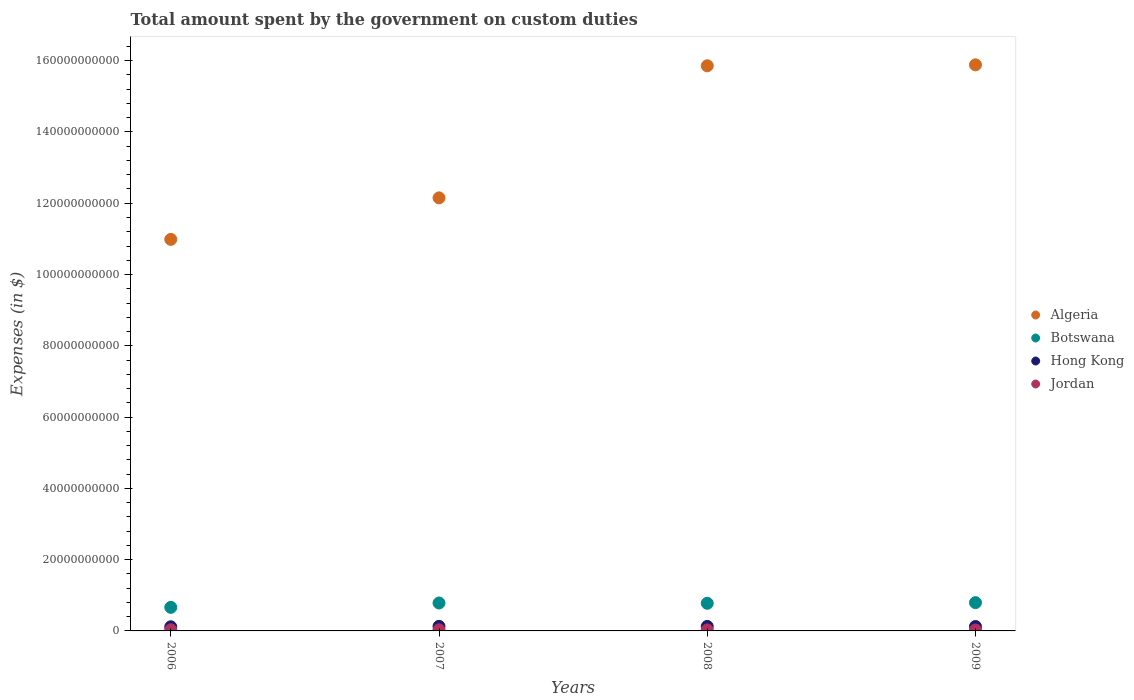Is the number of dotlines equal to the number of legend labels?
Your response must be concise. Yes. What is the amount spent on custom duties by the government in Algeria in 2009?
Give a very brief answer. 1.59e+11. Across all years, what is the maximum amount spent on custom duties by the government in Hong Kong?
Ensure brevity in your answer.  1.28e+09. Across all years, what is the minimum amount spent on custom duties by the government in Algeria?
Your answer should be compact. 1.10e+11. In which year was the amount spent on custom duties by the government in Jordan minimum?
Your response must be concise. 2009. What is the total amount spent on custom duties by the government in Botswana in the graph?
Your response must be concise. 3.01e+1. What is the difference between the amount spent on custom duties by the government in Hong Kong in 2007 and that in 2009?
Make the answer very short. 4.30e+07. What is the difference between the amount spent on custom duties by the government in Algeria in 2008 and the amount spent on custom duties by the government in Jordan in 2007?
Ensure brevity in your answer.  1.58e+11. What is the average amount spent on custom duties by the government in Botswana per year?
Give a very brief answer. 7.53e+09. In the year 2007, what is the difference between the amount spent on custom duties by the government in Algeria and amount spent on custom duties by the government in Jordan?
Your answer should be very brief. 1.21e+11. What is the ratio of the amount spent on custom duties by the government in Botswana in 2006 to that in 2007?
Provide a short and direct response. 0.84. Is the amount spent on custom duties by the government in Hong Kong in 2006 less than that in 2007?
Provide a short and direct response. Yes. What is the difference between the highest and the second highest amount spent on custom duties by the government in Botswana?
Your answer should be compact. 9.62e+07. What is the difference between the highest and the lowest amount spent on custom duties by the government in Jordan?
Offer a terse response. 4.53e+07. In how many years, is the amount spent on custom duties by the government in Botswana greater than the average amount spent on custom duties by the government in Botswana taken over all years?
Keep it short and to the point. 3. Is the sum of the amount spent on custom duties by the government in Botswana in 2007 and 2008 greater than the maximum amount spent on custom duties by the government in Algeria across all years?
Make the answer very short. No. Is it the case that in every year, the sum of the amount spent on custom duties by the government in Hong Kong and amount spent on custom duties by the government in Botswana  is greater than the sum of amount spent on custom duties by the government in Algeria and amount spent on custom duties by the government in Jordan?
Ensure brevity in your answer.  Yes. Is it the case that in every year, the sum of the amount spent on custom duties by the government in Botswana and amount spent on custom duties by the government in Algeria  is greater than the amount spent on custom duties by the government in Jordan?
Offer a very short reply. Yes. Is the amount spent on custom duties by the government in Algeria strictly greater than the amount spent on custom duties by the government in Hong Kong over the years?
Your answer should be compact. Yes. How many dotlines are there?
Your answer should be compact. 4. How many years are there in the graph?
Make the answer very short. 4. Does the graph contain any zero values?
Keep it short and to the point. No. How are the legend labels stacked?
Your answer should be compact. Vertical. What is the title of the graph?
Offer a terse response. Total amount spent by the government on custom duties. Does "Croatia" appear as one of the legend labels in the graph?
Ensure brevity in your answer.  No. What is the label or title of the X-axis?
Make the answer very short. Years. What is the label or title of the Y-axis?
Keep it short and to the point. Expenses (in $). What is the Expenses (in $) in Algeria in 2006?
Provide a short and direct response. 1.10e+11. What is the Expenses (in $) in Botswana in 2006?
Give a very brief answer. 6.61e+09. What is the Expenses (in $) in Hong Kong in 2006?
Your response must be concise. 1.16e+09. What is the Expenses (in $) in Jordan in 2006?
Your response must be concise. 3.16e+08. What is the Expenses (in $) in Algeria in 2007?
Keep it short and to the point. 1.22e+11. What is the Expenses (in $) of Botswana in 2007?
Provide a succinct answer. 7.83e+09. What is the Expenses (in $) in Hong Kong in 2007?
Your response must be concise. 1.28e+09. What is the Expenses (in $) of Jordan in 2007?
Keep it short and to the point. 3.12e+08. What is the Expenses (in $) of Algeria in 2008?
Keep it short and to the point. 1.59e+11. What is the Expenses (in $) of Botswana in 2008?
Make the answer very short. 7.75e+09. What is the Expenses (in $) of Hong Kong in 2008?
Provide a short and direct response. 1.26e+09. What is the Expenses (in $) of Jordan in 2008?
Your response must be concise. 2.84e+08. What is the Expenses (in $) in Algeria in 2009?
Your answer should be very brief. 1.59e+11. What is the Expenses (in $) in Botswana in 2009?
Offer a very short reply. 7.93e+09. What is the Expenses (in $) of Hong Kong in 2009?
Your response must be concise. 1.24e+09. What is the Expenses (in $) of Jordan in 2009?
Offer a terse response. 2.70e+08. Across all years, what is the maximum Expenses (in $) of Algeria?
Your response must be concise. 1.59e+11. Across all years, what is the maximum Expenses (in $) of Botswana?
Make the answer very short. 7.93e+09. Across all years, what is the maximum Expenses (in $) in Hong Kong?
Keep it short and to the point. 1.28e+09. Across all years, what is the maximum Expenses (in $) of Jordan?
Give a very brief answer. 3.16e+08. Across all years, what is the minimum Expenses (in $) in Algeria?
Your answer should be very brief. 1.10e+11. Across all years, what is the minimum Expenses (in $) in Botswana?
Offer a terse response. 6.61e+09. Across all years, what is the minimum Expenses (in $) in Hong Kong?
Your response must be concise. 1.16e+09. Across all years, what is the minimum Expenses (in $) in Jordan?
Offer a very short reply. 2.70e+08. What is the total Expenses (in $) in Algeria in the graph?
Your answer should be compact. 5.49e+11. What is the total Expenses (in $) in Botswana in the graph?
Give a very brief answer. 3.01e+1. What is the total Expenses (in $) in Hong Kong in the graph?
Ensure brevity in your answer.  4.94e+09. What is the total Expenses (in $) of Jordan in the graph?
Make the answer very short. 1.18e+09. What is the difference between the Expenses (in $) in Algeria in 2006 and that in 2007?
Make the answer very short. -1.16e+1. What is the difference between the Expenses (in $) in Botswana in 2006 and that in 2007?
Your response must be concise. -1.22e+09. What is the difference between the Expenses (in $) of Hong Kong in 2006 and that in 2007?
Your answer should be very brief. -1.18e+08. What is the difference between the Expenses (in $) of Jordan in 2006 and that in 2007?
Offer a very short reply. 3.54e+06. What is the difference between the Expenses (in $) in Algeria in 2006 and that in 2008?
Ensure brevity in your answer.  -4.87e+1. What is the difference between the Expenses (in $) of Botswana in 2006 and that in 2008?
Keep it short and to the point. -1.14e+09. What is the difference between the Expenses (in $) of Hong Kong in 2006 and that in 2008?
Your response must be concise. -1.02e+08. What is the difference between the Expenses (in $) in Jordan in 2006 and that in 2008?
Your answer should be very brief. 3.12e+07. What is the difference between the Expenses (in $) of Algeria in 2006 and that in 2009?
Your answer should be very brief. -4.90e+1. What is the difference between the Expenses (in $) in Botswana in 2006 and that in 2009?
Offer a terse response. -1.32e+09. What is the difference between the Expenses (in $) in Hong Kong in 2006 and that in 2009?
Provide a short and direct response. -7.50e+07. What is the difference between the Expenses (in $) in Jordan in 2006 and that in 2009?
Ensure brevity in your answer.  4.53e+07. What is the difference between the Expenses (in $) in Algeria in 2007 and that in 2008?
Ensure brevity in your answer.  -3.71e+1. What is the difference between the Expenses (in $) of Botswana in 2007 and that in 2008?
Provide a short and direct response. 8.47e+07. What is the difference between the Expenses (in $) in Hong Kong in 2007 and that in 2008?
Offer a very short reply. 1.60e+07. What is the difference between the Expenses (in $) in Jordan in 2007 and that in 2008?
Make the answer very short. 2.77e+07. What is the difference between the Expenses (in $) in Algeria in 2007 and that in 2009?
Offer a very short reply. -3.73e+1. What is the difference between the Expenses (in $) of Botswana in 2007 and that in 2009?
Your response must be concise. -9.62e+07. What is the difference between the Expenses (in $) of Hong Kong in 2007 and that in 2009?
Keep it short and to the point. 4.30e+07. What is the difference between the Expenses (in $) in Jordan in 2007 and that in 2009?
Your answer should be compact. 4.18e+07. What is the difference between the Expenses (in $) of Algeria in 2008 and that in 2009?
Keep it short and to the point. -2.69e+08. What is the difference between the Expenses (in $) in Botswana in 2008 and that in 2009?
Keep it short and to the point. -1.81e+08. What is the difference between the Expenses (in $) of Hong Kong in 2008 and that in 2009?
Offer a terse response. 2.70e+07. What is the difference between the Expenses (in $) of Jordan in 2008 and that in 2009?
Your response must be concise. 1.41e+07. What is the difference between the Expenses (in $) of Algeria in 2006 and the Expenses (in $) of Botswana in 2007?
Ensure brevity in your answer.  1.02e+11. What is the difference between the Expenses (in $) in Algeria in 2006 and the Expenses (in $) in Hong Kong in 2007?
Ensure brevity in your answer.  1.09e+11. What is the difference between the Expenses (in $) in Algeria in 2006 and the Expenses (in $) in Jordan in 2007?
Offer a very short reply. 1.10e+11. What is the difference between the Expenses (in $) of Botswana in 2006 and the Expenses (in $) of Hong Kong in 2007?
Your answer should be very brief. 5.33e+09. What is the difference between the Expenses (in $) of Botswana in 2006 and the Expenses (in $) of Jordan in 2007?
Offer a very short reply. 6.30e+09. What is the difference between the Expenses (in $) of Hong Kong in 2006 and the Expenses (in $) of Jordan in 2007?
Give a very brief answer. 8.49e+08. What is the difference between the Expenses (in $) in Algeria in 2006 and the Expenses (in $) in Botswana in 2008?
Make the answer very short. 1.02e+11. What is the difference between the Expenses (in $) in Algeria in 2006 and the Expenses (in $) in Hong Kong in 2008?
Offer a very short reply. 1.09e+11. What is the difference between the Expenses (in $) of Algeria in 2006 and the Expenses (in $) of Jordan in 2008?
Give a very brief answer. 1.10e+11. What is the difference between the Expenses (in $) in Botswana in 2006 and the Expenses (in $) in Hong Kong in 2008?
Offer a terse response. 5.35e+09. What is the difference between the Expenses (in $) in Botswana in 2006 and the Expenses (in $) in Jordan in 2008?
Your answer should be very brief. 6.33e+09. What is the difference between the Expenses (in $) of Hong Kong in 2006 and the Expenses (in $) of Jordan in 2008?
Your response must be concise. 8.77e+08. What is the difference between the Expenses (in $) in Algeria in 2006 and the Expenses (in $) in Botswana in 2009?
Provide a succinct answer. 1.02e+11. What is the difference between the Expenses (in $) of Algeria in 2006 and the Expenses (in $) of Hong Kong in 2009?
Keep it short and to the point. 1.09e+11. What is the difference between the Expenses (in $) of Algeria in 2006 and the Expenses (in $) of Jordan in 2009?
Your response must be concise. 1.10e+11. What is the difference between the Expenses (in $) in Botswana in 2006 and the Expenses (in $) in Hong Kong in 2009?
Your response must be concise. 5.37e+09. What is the difference between the Expenses (in $) of Botswana in 2006 and the Expenses (in $) of Jordan in 2009?
Your answer should be very brief. 6.34e+09. What is the difference between the Expenses (in $) in Hong Kong in 2006 and the Expenses (in $) in Jordan in 2009?
Keep it short and to the point. 8.91e+08. What is the difference between the Expenses (in $) in Algeria in 2007 and the Expenses (in $) in Botswana in 2008?
Provide a succinct answer. 1.14e+11. What is the difference between the Expenses (in $) in Algeria in 2007 and the Expenses (in $) in Hong Kong in 2008?
Your answer should be compact. 1.20e+11. What is the difference between the Expenses (in $) in Algeria in 2007 and the Expenses (in $) in Jordan in 2008?
Give a very brief answer. 1.21e+11. What is the difference between the Expenses (in $) of Botswana in 2007 and the Expenses (in $) of Hong Kong in 2008?
Your response must be concise. 6.57e+09. What is the difference between the Expenses (in $) of Botswana in 2007 and the Expenses (in $) of Jordan in 2008?
Offer a very short reply. 7.55e+09. What is the difference between the Expenses (in $) of Hong Kong in 2007 and the Expenses (in $) of Jordan in 2008?
Your response must be concise. 9.95e+08. What is the difference between the Expenses (in $) of Algeria in 2007 and the Expenses (in $) of Botswana in 2009?
Your answer should be compact. 1.14e+11. What is the difference between the Expenses (in $) in Algeria in 2007 and the Expenses (in $) in Hong Kong in 2009?
Offer a terse response. 1.20e+11. What is the difference between the Expenses (in $) in Algeria in 2007 and the Expenses (in $) in Jordan in 2009?
Your answer should be compact. 1.21e+11. What is the difference between the Expenses (in $) in Botswana in 2007 and the Expenses (in $) in Hong Kong in 2009?
Keep it short and to the point. 6.60e+09. What is the difference between the Expenses (in $) of Botswana in 2007 and the Expenses (in $) of Jordan in 2009?
Provide a short and direct response. 7.56e+09. What is the difference between the Expenses (in $) in Hong Kong in 2007 and the Expenses (in $) in Jordan in 2009?
Make the answer very short. 1.01e+09. What is the difference between the Expenses (in $) of Algeria in 2008 and the Expenses (in $) of Botswana in 2009?
Provide a succinct answer. 1.51e+11. What is the difference between the Expenses (in $) of Algeria in 2008 and the Expenses (in $) of Hong Kong in 2009?
Make the answer very short. 1.57e+11. What is the difference between the Expenses (in $) of Algeria in 2008 and the Expenses (in $) of Jordan in 2009?
Offer a very short reply. 1.58e+11. What is the difference between the Expenses (in $) of Botswana in 2008 and the Expenses (in $) of Hong Kong in 2009?
Offer a terse response. 6.51e+09. What is the difference between the Expenses (in $) in Botswana in 2008 and the Expenses (in $) in Jordan in 2009?
Ensure brevity in your answer.  7.48e+09. What is the difference between the Expenses (in $) in Hong Kong in 2008 and the Expenses (in $) in Jordan in 2009?
Your answer should be compact. 9.93e+08. What is the average Expenses (in $) of Algeria per year?
Provide a short and direct response. 1.37e+11. What is the average Expenses (in $) of Botswana per year?
Give a very brief answer. 7.53e+09. What is the average Expenses (in $) of Hong Kong per year?
Your answer should be compact. 1.23e+09. What is the average Expenses (in $) in Jordan per year?
Offer a very short reply. 2.96e+08. In the year 2006, what is the difference between the Expenses (in $) in Algeria and Expenses (in $) in Botswana?
Ensure brevity in your answer.  1.03e+11. In the year 2006, what is the difference between the Expenses (in $) of Algeria and Expenses (in $) of Hong Kong?
Ensure brevity in your answer.  1.09e+11. In the year 2006, what is the difference between the Expenses (in $) in Algeria and Expenses (in $) in Jordan?
Offer a very short reply. 1.10e+11. In the year 2006, what is the difference between the Expenses (in $) of Botswana and Expenses (in $) of Hong Kong?
Ensure brevity in your answer.  5.45e+09. In the year 2006, what is the difference between the Expenses (in $) of Botswana and Expenses (in $) of Jordan?
Make the answer very short. 6.29e+09. In the year 2006, what is the difference between the Expenses (in $) in Hong Kong and Expenses (in $) in Jordan?
Provide a succinct answer. 8.45e+08. In the year 2007, what is the difference between the Expenses (in $) of Algeria and Expenses (in $) of Botswana?
Provide a succinct answer. 1.14e+11. In the year 2007, what is the difference between the Expenses (in $) of Algeria and Expenses (in $) of Hong Kong?
Make the answer very short. 1.20e+11. In the year 2007, what is the difference between the Expenses (in $) in Algeria and Expenses (in $) in Jordan?
Keep it short and to the point. 1.21e+11. In the year 2007, what is the difference between the Expenses (in $) of Botswana and Expenses (in $) of Hong Kong?
Make the answer very short. 6.56e+09. In the year 2007, what is the difference between the Expenses (in $) in Botswana and Expenses (in $) in Jordan?
Provide a short and direct response. 7.52e+09. In the year 2007, what is the difference between the Expenses (in $) in Hong Kong and Expenses (in $) in Jordan?
Your answer should be very brief. 9.67e+08. In the year 2008, what is the difference between the Expenses (in $) of Algeria and Expenses (in $) of Botswana?
Offer a terse response. 1.51e+11. In the year 2008, what is the difference between the Expenses (in $) in Algeria and Expenses (in $) in Hong Kong?
Make the answer very short. 1.57e+11. In the year 2008, what is the difference between the Expenses (in $) in Algeria and Expenses (in $) in Jordan?
Provide a succinct answer. 1.58e+11. In the year 2008, what is the difference between the Expenses (in $) of Botswana and Expenses (in $) of Hong Kong?
Your answer should be compact. 6.49e+09. In the year 2008, what is the difference between the Expenses (in $) of Botswana and Expenses (in $) of Jordan?
Your answer should be compact. 7.47e+09. In the year 2008, what is the difference between the Expenses (in $) in Hong Kong and Expenses (in $) in Jordan?
Keep it short and to the point. 9.79e+08. In the year 2009, what is the difference between the Expenses (in $) in Algeria and Expenses (in $) in Botswana?
Offer a terse response. 1.51e+11. In the year 2009, what is the difference between the Expenses (in $) of Algeria and Expenses (in $) of Hong Kong?
Ensure brevity in your answer.  1.58e+11. In the year 2009, what is the difference between the Expenses (in $) in Algeria and Expenses (in $) in Jordan?
Provide a short and direct response. 1.59e+11. In the year 2009, what is the difference between the Expenses (in $) of Botswana and Expenses (in $) of Hong Kong?
Offer a very short reply. 6.70e+09. In the year 2009, what is the difference between the Expenses (in $) in Botswana and Expenses (in $) in Jordan?
Your answer should be very brief. 7.66e+09. In the year 2009, what is the difference between the Expenses (in $) of Hong Kong and Expenses (in $) of Jordan?
Your response must be concise. 9.66e+08. What is the ratio of the Expenses (in $) of Algeria in 2006 to that in 2007?
Offer a terse response. 0.9. What is the ratio of the Expenses (in $) of Botswana in 2006 to that in 2007?
Ensure brevity in your answer.  0.84. What is the ratio of the Expenses (in $) of Hong Kong in 2006 to that in 2007?
Your answer should be very brief. 0.91. What is the ratio of the Expenses (in $) of Jordan in 2006 to that in 2007?
Offer a very short reply. 1.01. What is the ratio of the Expenses (in $) of Algeria in 2006 to that in 2008?
Ensure brevity in your answer.  0.69. What is the ratio of the Expenses (in $) in Botswana in 2006 to that in 2008?
Offer a very short reply. 0.85. What is the ratio of the Expenses (in $) of Hong Kong in 2006 to that in 2008?
Offer a very short reply. 0.92. What is the ratio of the Expenses (in $) in Jordan in 2006 to that in 2008?
Ensure brevity in your answer.  1.11. What is the ratio of the Expenses (in $) in Algeria in 2006 to that in 2009?
Provide a short and direct response. 0.69. What is the ratio of the Expenses (in $) of Botswana in 2006 to that in 2009?
Make the answer very short. 0.83. What is the ratio of the Expenses (in $) of Hong Kong in 2006 to that in 2009?
Provide a short and direct response. 0.94. What is the ratio of the Expenses (in $) of Jordan in 2006 to that in 2009?
Your response must be concise. 1.17. What is the ratio of the Expenses (in $) in Algeria in 2007 to that in 2008?
Your answer should be very brief. 0.77. What is the ratio of the Expenses (in $) in Botswana in 2007 to that in 2008?
Ensure brevity in your answer.  1.01. What is the ratio of the Expenses (in $) in Hong Kong in 2007 to that in 2008?
Make the answer very short. 1.01. What is the ratio of the Expenses (in $) of Jordan in 2007 to that in 2008?
Provide a short and direct response. 1.1. What is the ratio of the Expenses (in $) in Algeria in 2007 to that in 2009?
Ensure brevity in your answer.  0.77. What is the ratio of the Expenses (in $) in Botswana in 2007 to that in 2009?
Your response must be concise. 0.99. What is the ratio of the Expenses (in $) of Hong Kong in 2007 to that in 2009?
Your response must be concise. 1.03. What is the ratio of the Expenses (in $) in Jordan in 2007 to that in 2009?
Provide a short and direct response. 1.15. What is the ratio of the Expenses (in $) in Algeria in 2008 to that in 2009?
Provide a succinct answer. 1. What is the ratio of the Expenses (in $) of Botswana in 2008 to that in 2009?
Make the answer very short. 0.98. What is the ratio of the Expenses (in $) of Hong Kong in 2008 to that in 2009?
Your answer should be very brief. 1.02. What is the ratio of the Expenses (in $) in Jordan in 2008 to that in 2009?
Offer a terse response. 1.05. What is the difference between the highest and the second highest Expenses (in $) of Algeria?
Offer a very short reply. 2.69e+08. What is the difference between the highest and the second highest Expenses (in $) in Botswana?
Make the answer very short. 9.62e+07. What is the difference between the highest and the second highest Expenses (in $) in Hong Kong?
Provide a short and direct response. 1.60e+07. What is the difference between the highest and the second highest Expenses (in $) in Jordan?
Provide a short and direct response. 3.54e+06. What is the difference between the highest and the lowest Expenses (in $) of Algeria?
Your answer should be compact. 4.90e+1. What is the difference between the highest and the lowest Expenses (in $) of Botswana?
Keep it short and to the point. 1.32e+09. What is the difference between the highest and the lowest Expenses (in $) of Hong Kong?
Your answer should be very brief. 1.18e+08. What is the difference between the highest and the lowest Expenses (in $) of Jordan?
Offer a terse response. 4.53e+07. 